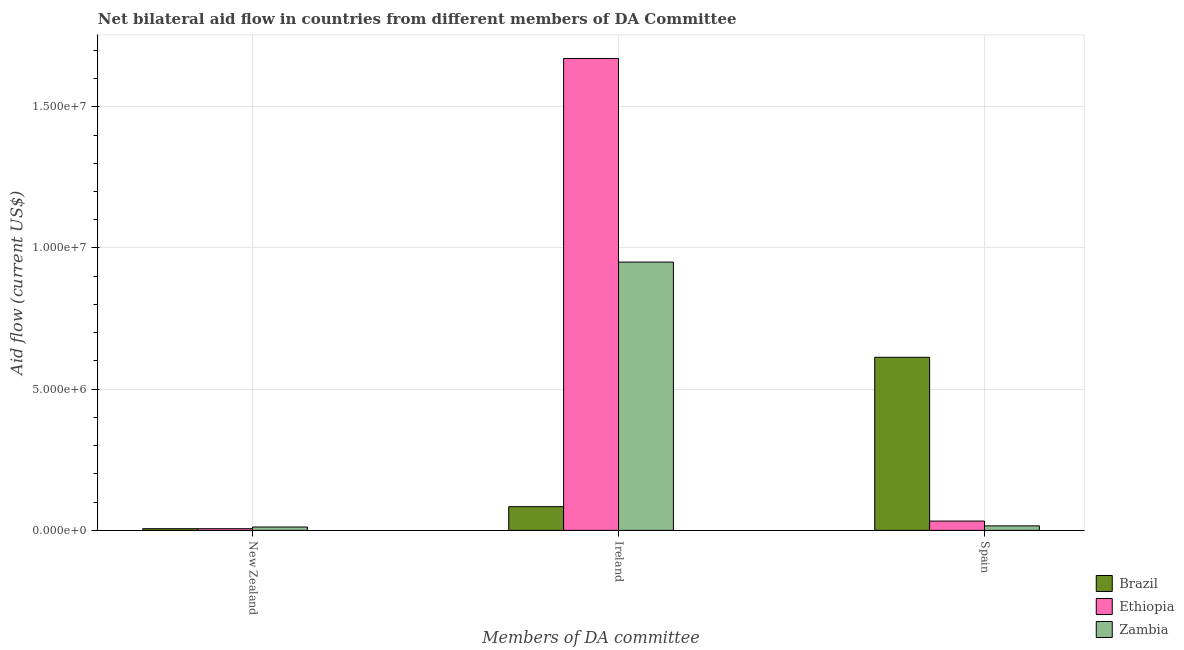How many groups of bars are there?
Keep it short and to the point. 3. Are the number of bars per tick equal to the number of legend labels?
Your answer should be compact. Yes. How many bars are there on the 3rd tick from the left?
Your response must be concise. 3. What is the label of the 1st group of bars from the left?
Offer a very short reply. New Zealand. What is the amount of aid provided by spain in Brazil?
Make the answer very short. 6.13e+06. Across all countries, what is the maximum amount of aid provided by spain?
Provide a succinct answer. 6.13e+06. Across all countries, what is the minimum amount of aid provided by spain?
Your response must be concise. 1.60e+05. In which country was the amount of aid provided by new zealand maximum?
Your response must be concise. Zambia. In which country was the amount of aid provided by spain minimum?
Offer a terse response. Zambia. What is the total amount of aid provided by new zealand in the graph?
Offer a terse response. 2.40e+05. What is the difference between the amount of aid provided by spain in Ethiopia and that in Zambia?
Your answer should be very brief. 1.70e+05. What is the difference between the amount of aid provided by new zealand in Brazil and the amount of aid provided by ireland in Ethiopia?
Your answer should be compact. -1.66e+07. What is the average amount of aid provided by ireland per country?
Ensure brevity in your answer.  9.02e+06. What is the difference between the amount of aid provided by ireland and amount of aid provided by new zealand in Ethiopia?
Ensure brevity in your answer.  1.66e+07. In how many countries, is the amount of aid provided by spain greater than 13000000 US$?
Your answer should be compact. 0. What is the ratio of the amount of aid provided by ireland in Brazil to that in Ethiopia?
Offer a very short reply. 0.05. What is the difference between the highest and the second highest amount of aid provided by spain?
Provide a succinct answer. 5.80e+06. What is the difference between the highest and the lowest amount of aid provided by new zealand?
Give a very brief answer. 6.00e+04. In how many countries, is the amount of aid provided by new zealand greater than the average amount of aid provided by new zealand taken over all countries?
Offer a very short reply. 1. What does the 3rd bar from the left in New Zealand represents?
Ensure brevity in your answer.  Zambia. What does the 2nd bar from the right in New Zealand represents?
Ensure brevity in your answer.  Ethiopia. Is it the case that in every country, the sum of the amount of aid provided by new zealand and amount of aid provided by ireland is greater than the amount of aid provided by spain?
Offer a terse response. No. Are all the bars in the graph horizontal?
Provide a short and direct response. No. What is the difference between two consecutive major ticks on the Y-axis?
Your answer should be compact. 5.00e+06. Are the values on the major ticks of Y-axis written in scientific E-notation?
Your answer should be compact. Yes. Does the graph contain grids?
Offer a very short reply. Yes. Where does the legend appear in the graph?
Your response must be concise. Bottom right. How are the legend labels stacked?
Your response must be concise. Vertical. What is the title of the graph?
Ensure brevity in your answer.  Net bilateral aid flow in countries from different members of DA Committee. Does "Cyprus" appear as one of the legend labels in the graph?
Keep it short and to the point. No. What is the label or title of the X-axis?
Your answer should be very brief. Members of DA committee. What is the label or title of the Y-axis?
Ensure brevity in your answer.  Aid flow (current US$). What is the Aid flow (current US$) in Brazil in New Zealand?
Give a very brief answer. 6.00e+04. What is the Aid flow (current US$) of Brazil in Ireland?
Provide a succinct answer. 8.40e+05. What is the Aid flow (current US$) of Ethiopia in Ireland?
Give a very brief answer. 1.67e+07. What is the Aid flow (current US$) of Zambia in Ireland?
Offer a terse response. 9.50e+06. What is the Aid flow (current US$) in Brazil in Spain?
Provide a short and direct response. 6.13e+06. What is the Aid flow (current US$) in Ethiopia in Spain?
Ensure brevity in your answer.  3.30e+05. What is the Aid flow (current US$) of Zambia in Spain?
Your response must be concise. 1.60e+05. Across all Members of DA committee, what is the maximum Aid flow (current US$) of Brazil?
Give a very brief answer. 6.13e+06. Across all Members of DA committee, what is the maximum Aid flow (current US$) in Ethiopia?
Give a very brief answer. 1.67e+07. Across all Members of DA committee, what is the maximum Aid flow (current US$) in Zambia?
Give a very brief answer. 9.50e+06. What is the total Aid flow (current US$) in Brazil in the graph?
Keep it short and to the point. 7.03e+06. What is the total Aid flow (current US$) of Ethiopia in the graph?
Offer a terse response. 1.71e+07. What is the total Aid flow (current US$) of Zambia in the graph?
Offer a very short reply. 9.78e+06. What is the difference between the Aid flow (current US$) of Brazil in New Zealand and that in Ireland?
Offer a very short reply. -7.80e+05. What is the difference between the Aid flow (current US$) of Ethiopia in New Zealand and that in Ireland?
Provide a succinct answer. -1.66e+07. What is the difference between the Aid flow (current US$) in Zambia in New Zealand and that in Ireland?
Give a very brief answer. -9.38e+06. What is the difference between the Aid flow (current US$) in Brazil in New Zealand and that in Spain?
Your answer should be very brief. -6.07e+06. What is the difference between the Aid flow (current US$) in Ethiopia in New Zealand and that in Spain?
Offer a terse response. -2.70e+05. What is the difference between the Aid flow (current US$) of Zambia in New Zealand and that in Spain?
Make the answer very short. -4.00e+04. What is the difference between the Aid flow (current US$) of Brazil in Ireland and that in Spain?
Keep it short and to the point. -5.29e+06. What is the difference between the Aid flow (current US$) in Ethiopia in Ireland and that in Spain?
Offer a terse response. 1.64e+07. What is the difference between the Aid flow (current US$) of Zambia in Ireland and that in Spain?
Ensure brevity in your answer.  9.34e+06. What is the difference between the Aid flow (current US$) in Brazil in New Zealand and the Aid flow (current US$) in Ethiopia in Ireland?
Ensure brevity in your answer.  -1.66e+07. What is the difference between the Aid flow (current US$) in Brazil in New Zealand and the Aid flow (current US$) in Zambia in Ireland?
Your answer should be compact. -9.44e+06. What is the difference between the Aid flow (current US$) in Ethiopia in New Zealand and the Aid flow (current US$) in Zambia in Ireland?
Your answer should be very brief. -9.44e+06. What is the difference between the Aid flow (current US$) in Brazil in New Zealand and the Aid flow (current US$) in Ethiopia in Spain?
Your response must be concise. -2.70e+05. What is the difference between the Aid flow (current US$) in Brazil in Ireland and the Aid flow (current US$) in Ethiopia in Spain?
Offer a very short reply. 5.10e+05. What is the difference between the Aid flow (current US$) of Brazil in Ireland and the Aid flow (current US$) of Zambia in Spain?
Your answer should be compact. 6.80e+05. What is the difference between the Aid flow (current US$) of Ethiopia in Ireland and the Aid flow (current US$) of Zambia in Spain?
Provide a short and direct response. 1.66e+07. What is the average Aid flow (current US$) in Brazil per Members of DA committee?
Offer a very short reply. 2.34e+06. What is the average Aid flow (current US$) of Ethiopia per Members of DA committee?
Offer a very short reply. 5.70e+06. What is the average Aid flow (current US$) in Zambia per Members of DA committee?
Provide a short and direct response. 3.26e+06. What is the difference between the Aid flow (current US$) of Brazil and Aid flow (current US$) of Ethiopia in New Zealand?
Your response must be concise. 0. What is the difference between the Aid flow (current US$) in Ethiopia and Aid flow (current US$) in Zambia in New Zealand?
Your response must be concise. -6.00e+04. What is the difference between the Aid flow (current US$) in Brazil and Aid flow (current US$) in Ethiopia in Ireland?
Offer a terse response. -1.59e+07. What is the difference between the Aid flow (current US$) in Brazil and Aid flow (current US$) in Zambia in Ireland?
Your response must be concise. -8.66e+06. What is the difference between the Aid flow (current US$) of Ethiopia and Aid flow (current US$) of Zambia in Ireland?
Your response must be concise. 7.21e+06. What is the difference between the Aid flow (current US$) in Brazil and Aid flow (current US$) in Ethiopia in Spain?
Offer a very short reply. 5.80e+06. What is the difference between the Aid flow (current US$) of Brazil and Aid flow (current US$) of Zambia in Spain?
Provide a succinct answer. 5.97e+06. What is the ratio of the Aid flow (current US$) in Brazil in New Zealand to that in Ireland?
Keep it short and to the point. 0.07. What is the ratio of the Aid flow (current US$) in Ethiopia in New Zealand to that in Ireland?
Provide a succinct answer. 0. What is the ratio of the Aid flow (current US$) of Zambia in New Zealand to that in Ireland?
Make the answer very short. 0.01. What is the ratio of the Aid flow (current US$) of Brazil in New Zealand to that in Spain?
Your answer should be compact. 0.01. What is the ratio of the Aid flow (current US$) of Ethiopia in New Zealand to that in Spain?
Your response must be concise. 0.18. What is the ratio of the Aid flow (current US$) in Zambia in New Zealand to that in Spain?
Your answer should be compact. 0.75. What is the ratio of the Aid flow (current US$) of Brazil in Ireland to that in Spain?
Give a very brief answer. 0.14. What is the ratio of the Aid flow (current US$) of Ethiopia in Ireland to that in Spain?
Offer a very short reply. 50.64. What is the ratio of the Aid flow (current US$) in Zambia in Ireland to that in Spain?
Ensure brevity in your answer.  59.38. What is the difference between the highest and the second highest Aid flow (current US$) of Brazil?
Your answer should be very brief. 5.29e+06. What is the difference between the highest and the second highest Aid flow (current US$) of Ethiopia?
Offer a terse response. 1.64e+07. What is the difference between the highest and the second highest Aid flow (current US$) in Zambia?
Your answer should be compact. 9.34e+06. What is the difference between the highest and the lowest Aid flow (current US$) of Brazil?
Offer a terse response. 6.07e+06. What is the difference between the highest and the lowest Aid flow (current US$) of Ethiopia?
Provide a succinct answer. 1.66e+07. What is the difference between the highest and the lowest Aid flow (current US$) of Zambia?
Your response must be concise. 9.38e+06. 